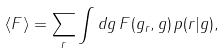<formula> <loc_0><loc_0><loc_500><loc_500>\langle F \rangle = \sum _ { r } \int d g \, F ( g _ { r } , g ) \, p ( r | g ) ,</formula> 